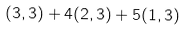Convert formula to latex. <formula><loc_0><loc_0><loc_500><loc_500>( 3 , 3 ) + 4 ( 2 , 3 ) + 5 ( 1 , 3 )</formula> 